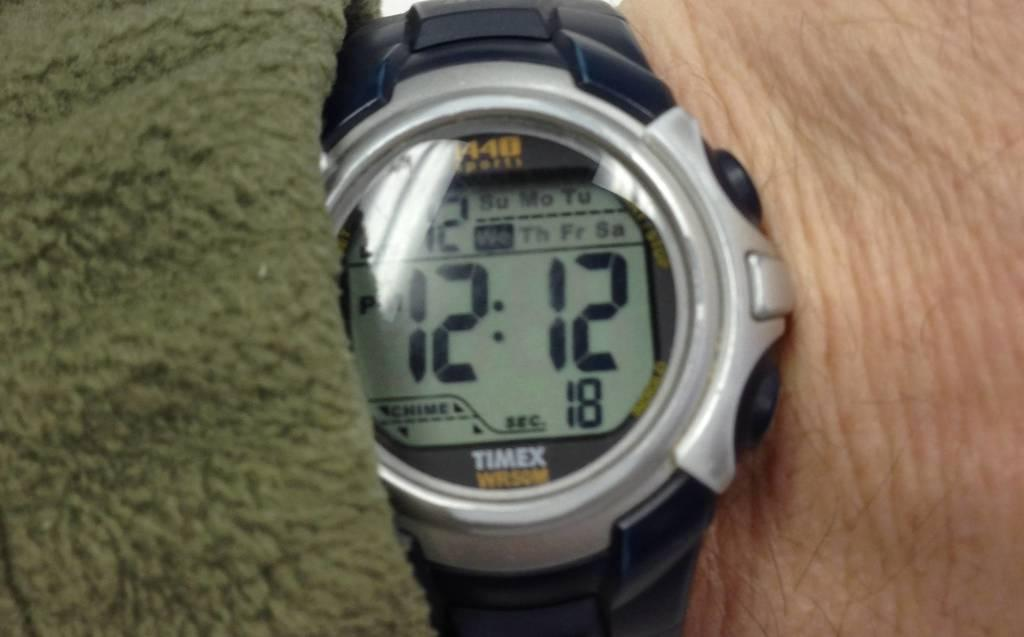<image>
Provide a brief description of the given image. A Timex watch displays a time of 12:12 pm. 